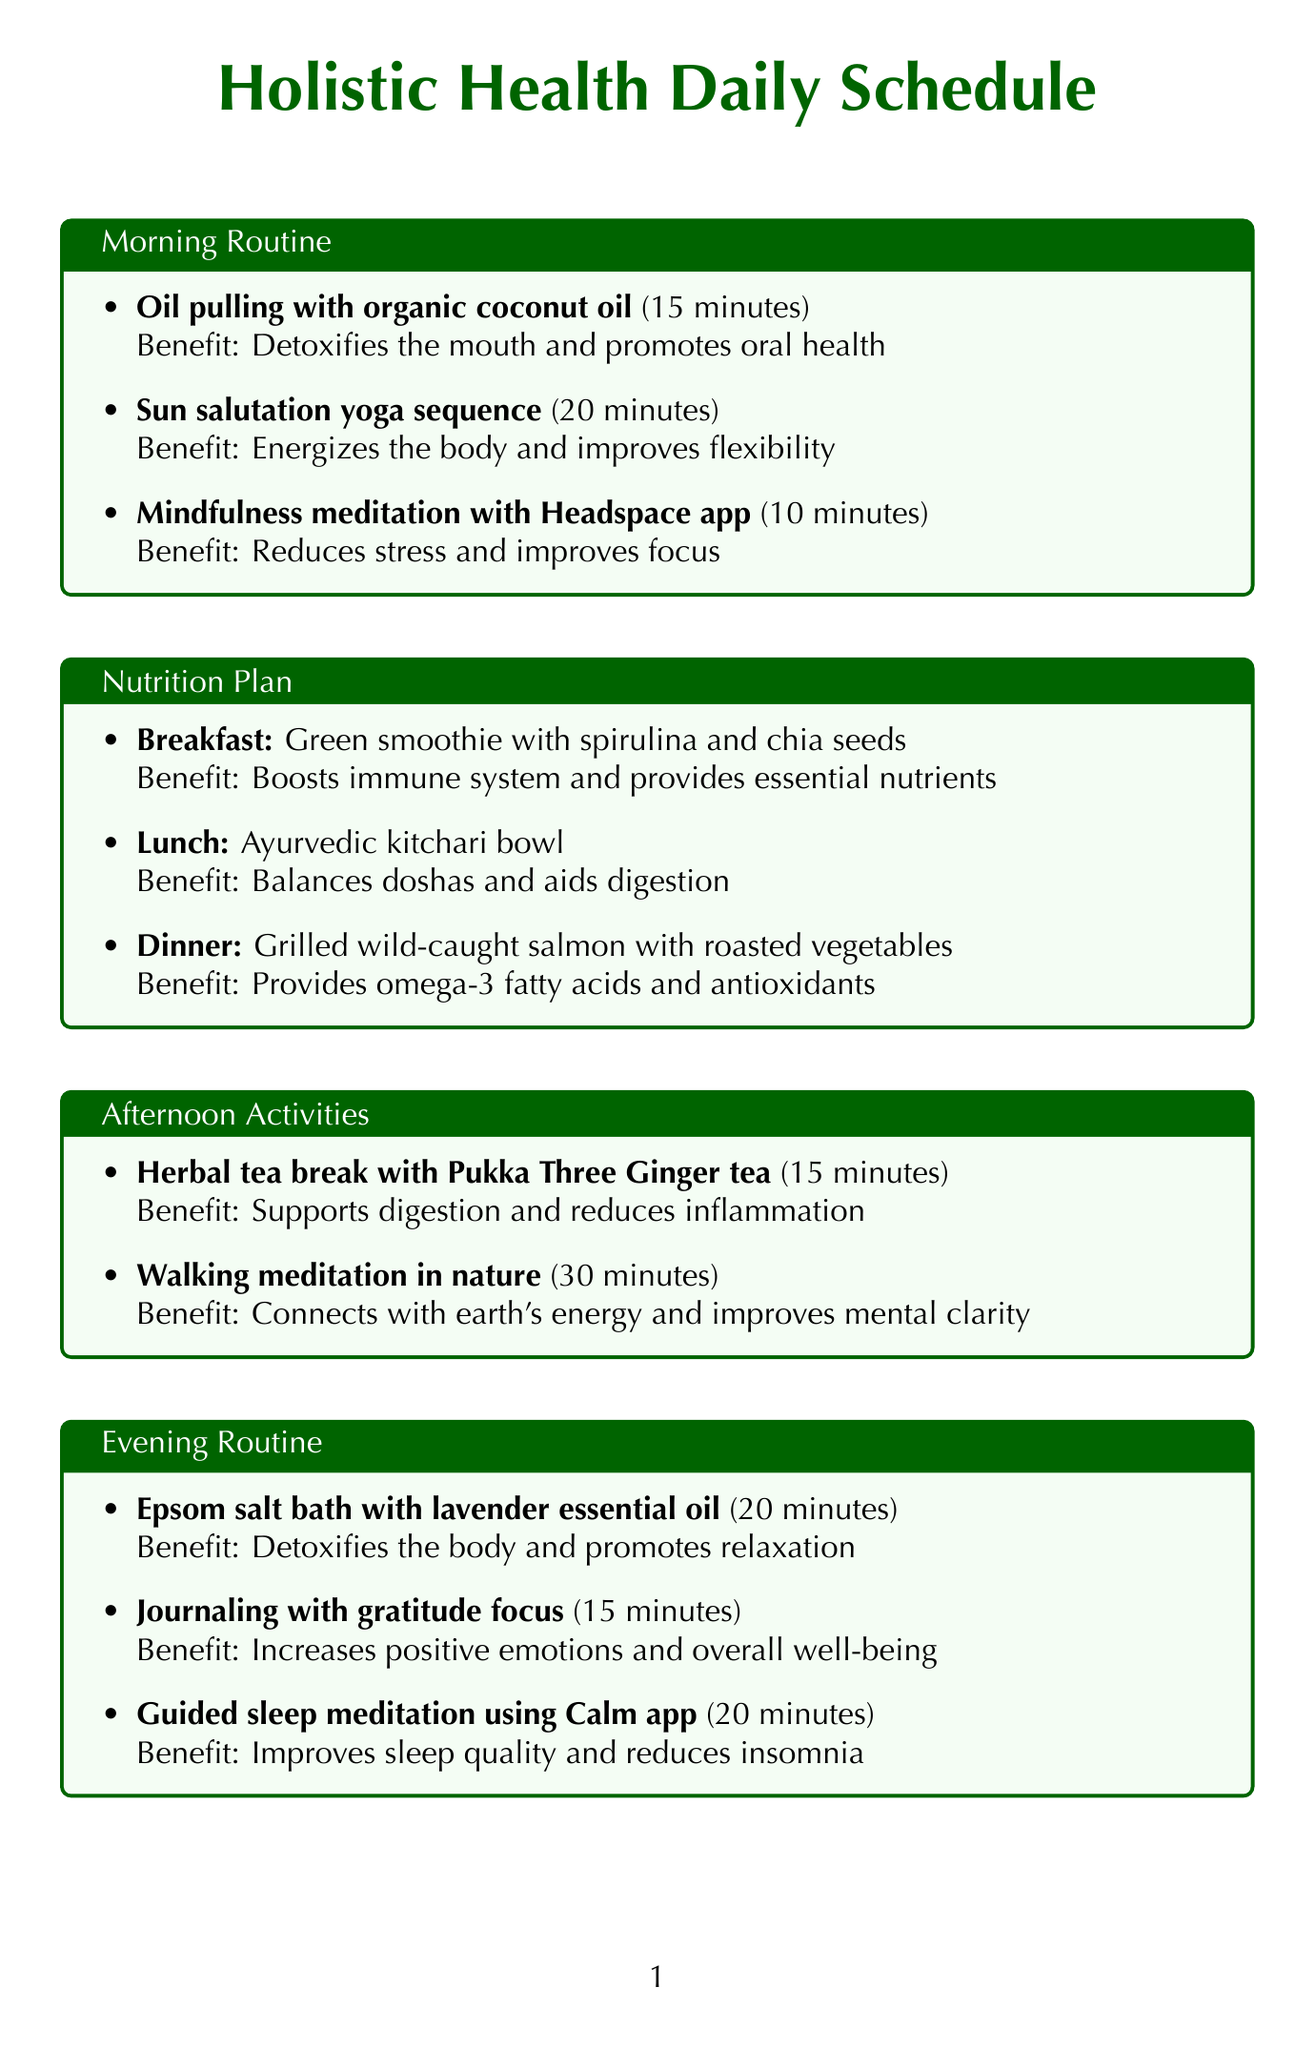What is the duration of the oil pulling activity? The document states that oil pulling with organic coconut oil lasts for 15 minutes.
Answer: 15 minutes What is the primary benefit of the green smoothie suggested for breakfast? The document indicates that the green smoothie boosts the immune system and provides essential nutrients.
Answer: Boosts immune system and provides essential nutrients How often is the acupuncture session recommended? According to the document, acupuncture sessions should be done once a week.
Answer: Once a week What activity is recommended for afternoon relaxation? The document mentions a herbal tea break with Pukka Three Ginger tea as an afternoon activity.
Answer: Herbal tea break with Pukka Three Ginger tea Which supplement is advised to be taken before bedtime? The document states that the Four Sigmatic Reishi Mushroom Elixir should be taken before bedtime.
Answer: Four Sigmatic Reishi Mushroom Elixir What is the benefit of journaling with a gratitude focus? The document explains that journaling increases positive emotions and overall well-being.
Answer: Increases positive emotions and overall well-being How long should the walking meditation last? According to the document, walking meditation in nature is recommended for 30 minutes.
Answer: 30 minutes What is the benefit of doing sun salutation yoga? The document states that sun salutation yoga sequence energizes the body and improves flexibility.
Answer: Energizes the body and improves flexibility 